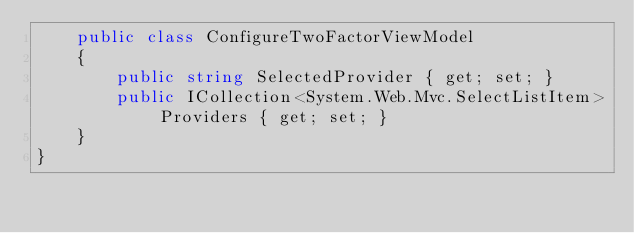<code> <loc_0><loc_0><loc_500><loc_500><_C#_>    public class ConfigureTwoFactorViewModel
    {
        public string SelectedProvider { get; set; }
        public ICollection<System.Web.Mvc.SelectListItem> Providers { get; set; }
    }
}</code> 